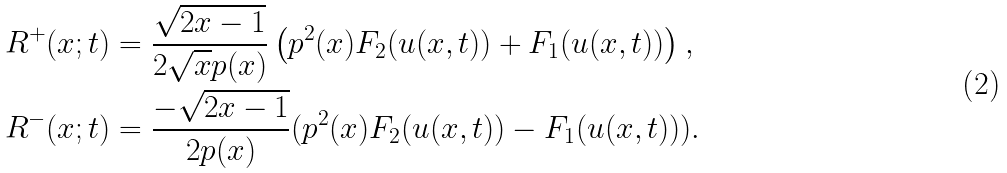<formula> <loc_0><loc_0><loc_500><loc_500>R ^ { + } ( x ; t ) & = \frac { \sqrt { 2 x - 1 } } { 2 \sqrt { x } p ( x ) } \left ( p ^ { 2 } ( x ) F _ { 2 } ( u ( x , t ) ) + F _ { 1 } ( u ( x , t ) ) \right ) , \\ R ^ { - } ( x ; t ) & = \frac { - \sqrt { 2 x - 1 } } { 2 p ( x ) } ( p ^ { 2 } ( x ) F _ { 2 } ( u ( x , t ) ) - F _ { 1 } ( u ( x , t ) ) ) .</formula> 